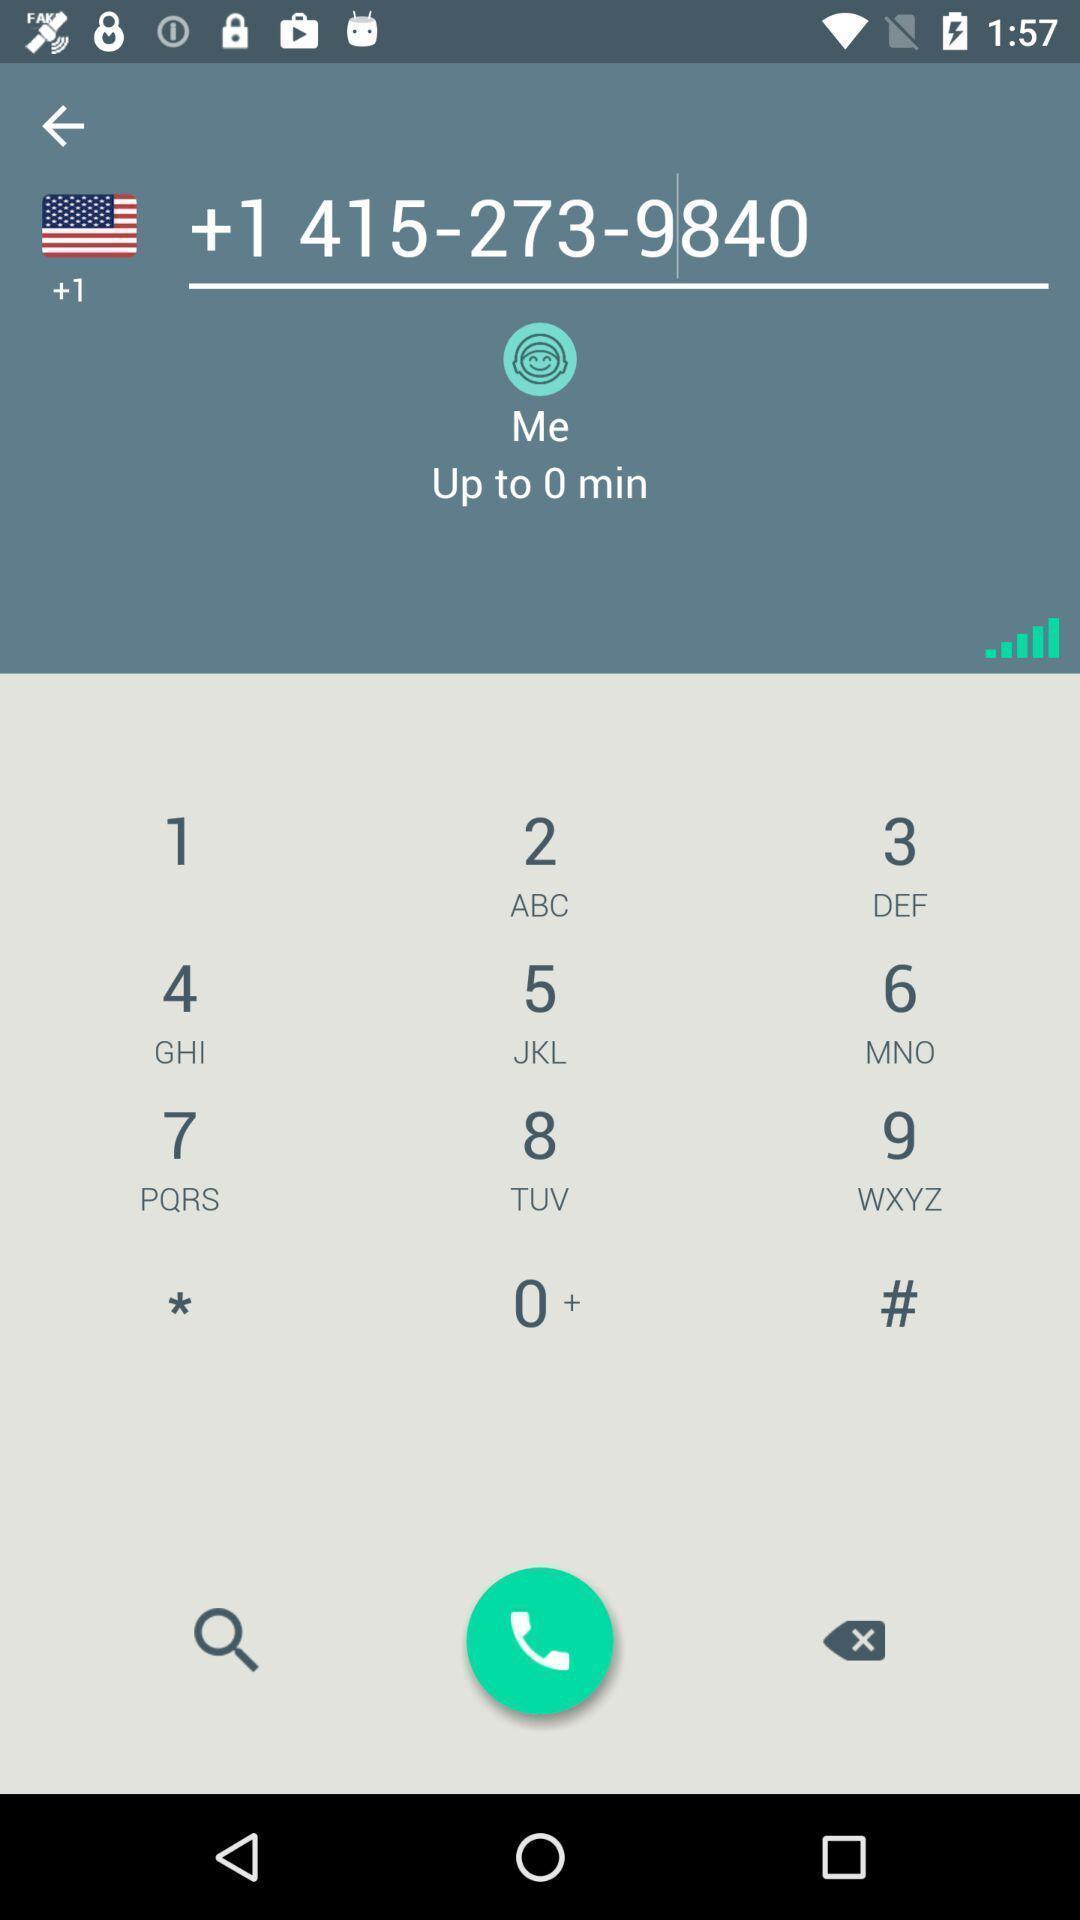Describe the key features of this screenshot. Screen displaying the dial pad for calling. 